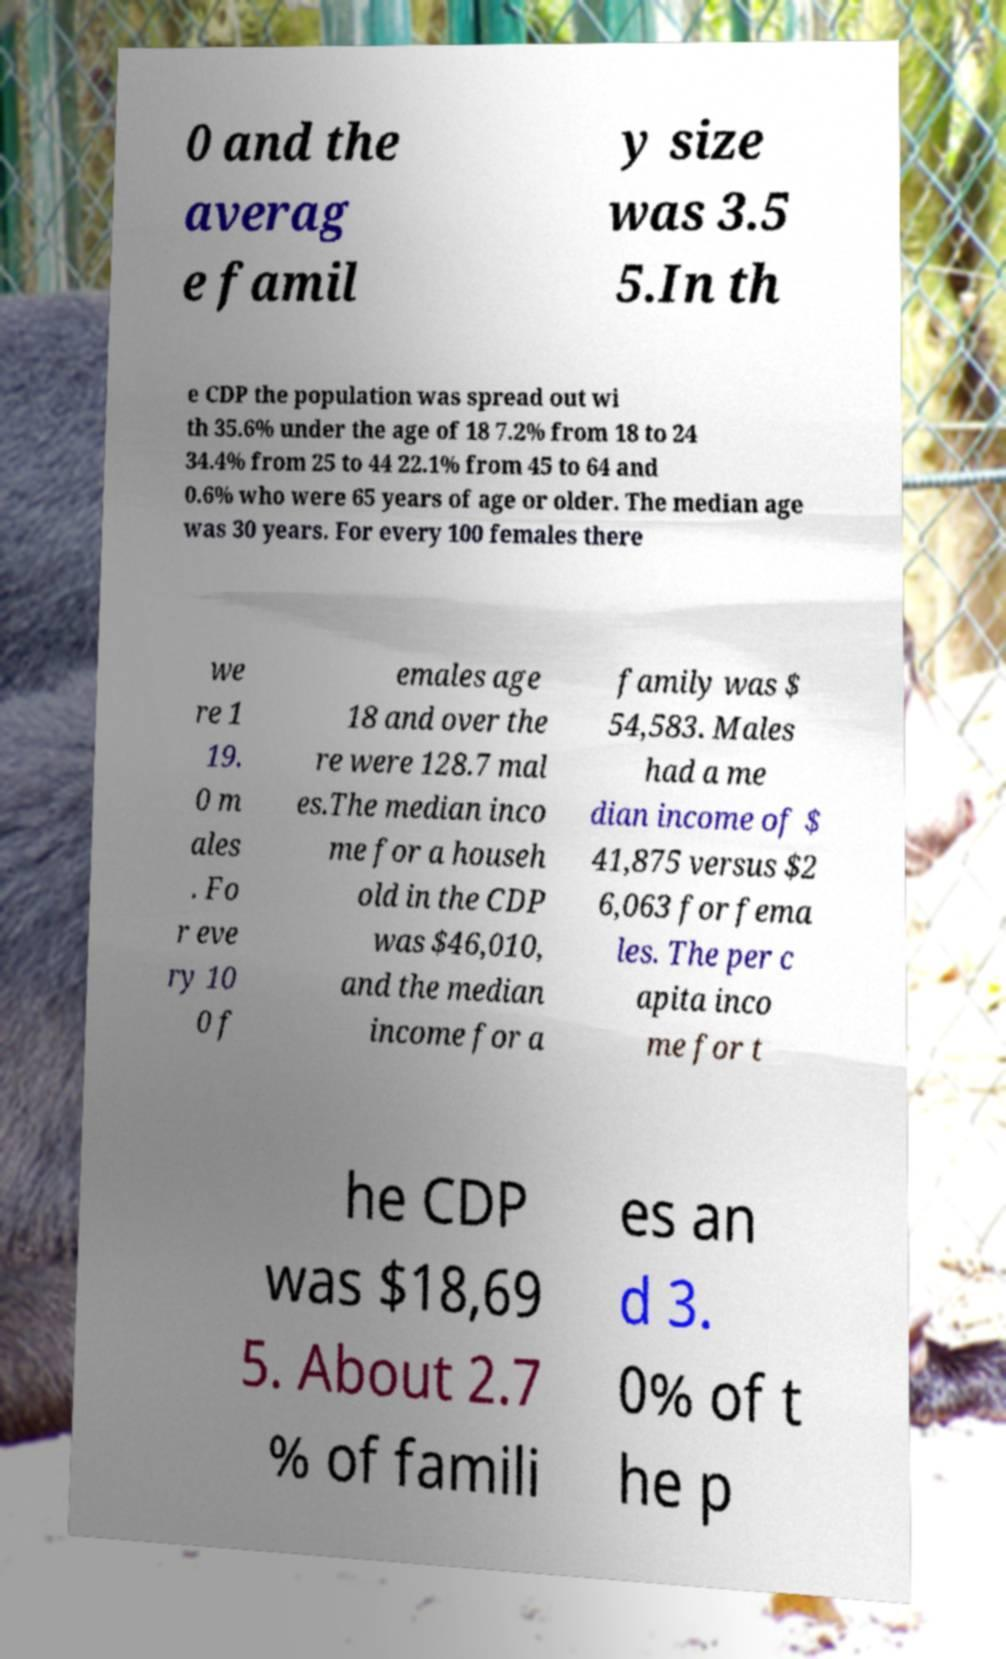Can you read and provide the text displayed in the image?This photo seems to have some interesting text. Can you extract and type it out for me? 0 and the averag e famil y size was 3.5 5.In th e CDP the population was spread out wi th 35.6% under the age of 18 7.2% from 18 to 24 34.4% from 25 to 44 22.1% from 45 to 64 and 0.6% who were 65 years of age or older. The median age was 30 years. For every 100 females there we re 1 19. 0 m ales . Fo r eve ry 10 0 f emales age 18 and over the re were 128.7 mal es.The median inco me for a househ old in the CDP was $46,010, and the median income for a family was $ 54,583. Males had a me dian income of $ 41,875 versus $2 6,063 for fema les. The per c apita inco me for t he CDP was $18,69 5. About 2.7 % of famili es an d 3. 0% of t he p 